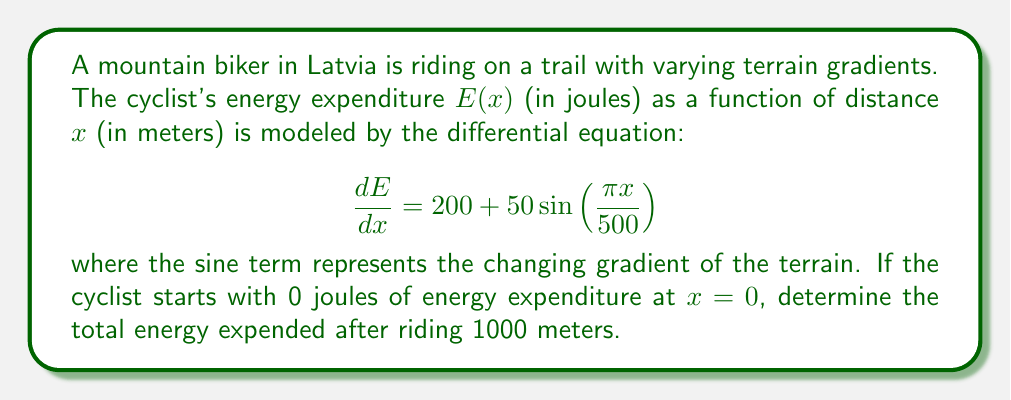Show me your answer to this math problem. To solve this problem, we need to integrate the given differential equation:

1) The equation is in the form $\frac{dE}{dx} = f(x)$, so we can find $E(x)$ by integrating both sides:

   $$E(x) = \int (200 + 50 \sin(\frac{\pi x}{500})) dx$$

2) Let's integrate term by term:
   
   $$E(x) = 200x - \frac{50 \cdot 500}{\pi} \cos(\frac{\pi x}{500}) + C$$

3) Simplify:
   
   $$E(x) = 200x - \frac{25000}{\pi} \cos(\frac{\pi x}{500}) + C$$

4) To find $C$, we use the initial condition $E(0) = 0$:

   $$0 = 200(0) - \frac{25000}{\pi} \cos(0) + C$$
   $$0 = -\frac{25000}{\pi} + C$$
   $$C = \frac{25000}{\pi}$$

5) Therefore, the general solution is:

   $$E(x) = 200x - \frac{25000}{\pi} \cos(\frac{\pi x}{500}) + \frac{25000}{\pi}$$

6) To find the energy expended after 1000 meters, we evaluate $E(1000)$:

   $$E(1000) = 200(1000) - \frac{25000}{\pi} \cos(\frac{\pi \cdot 1000}{500}) + \frac{25000}{\pi}$$
   $$= 200000 - \frac{25000}{\pi} \cos(2\pi) + \frac{25000}{\pi}$$
   $$= 200000 - \frac{25000}{\pi} + \frac{25000}{\pi}$$
   $$= 200000 \text{ joules}$$
Answer: The total energy expended after riding 1000 meters is 200000 joules. 